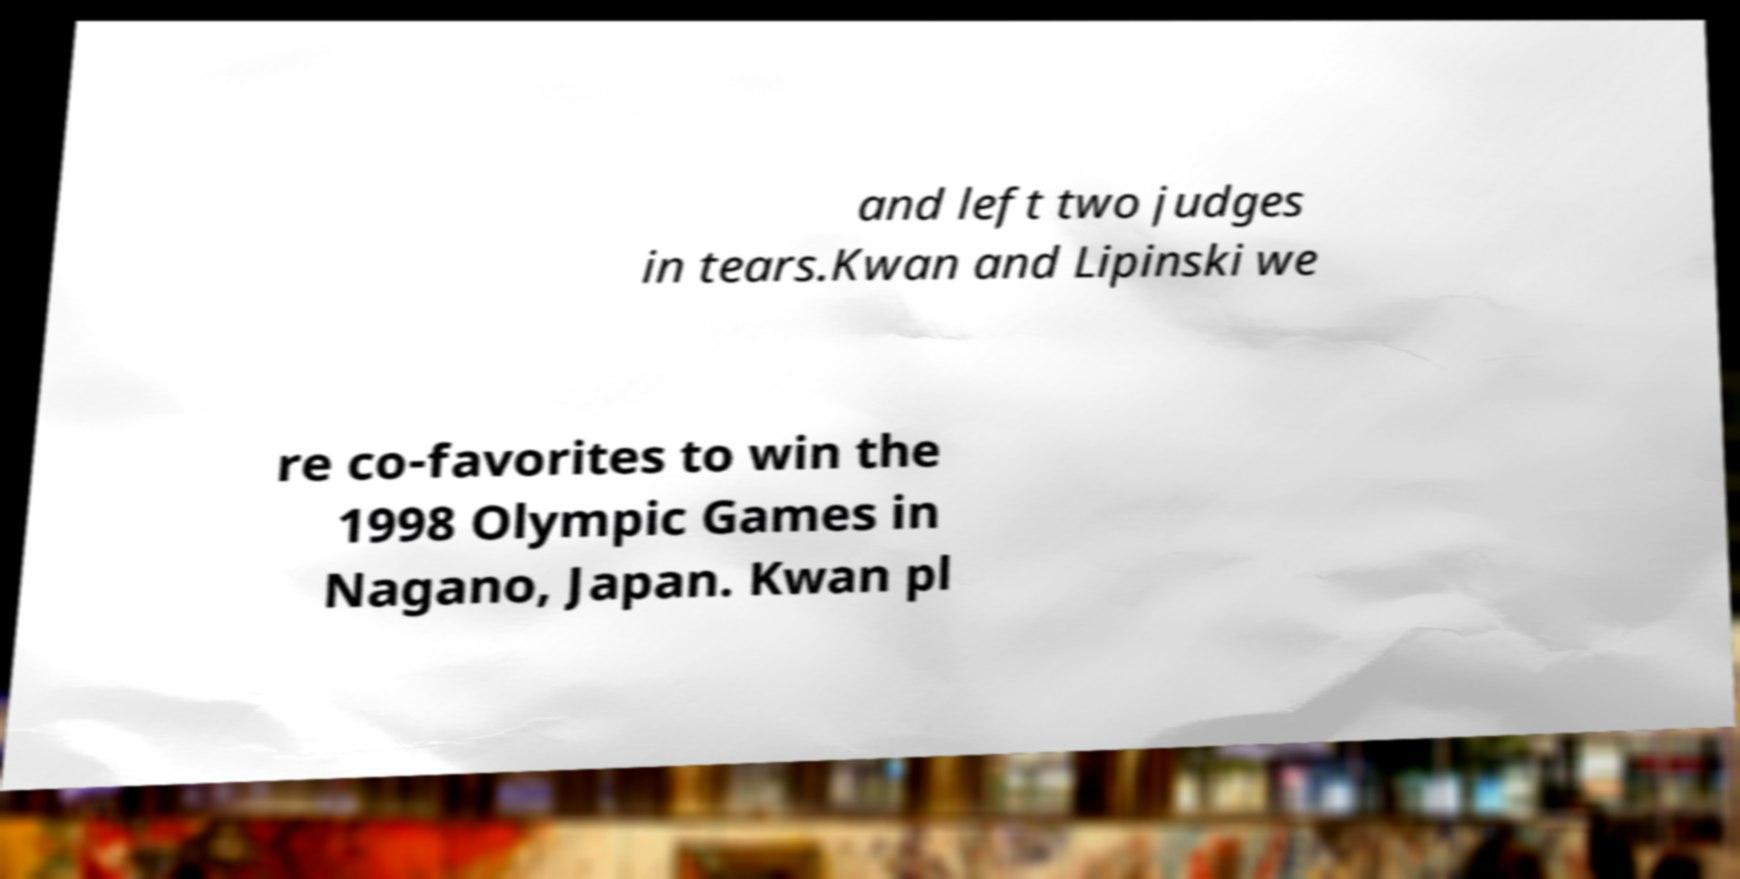Can you accurately transcribe the text from the provided image for me? and left two judges in tears.Kwan and Lipinski we re co-favorites to win the 1998 Olympic Games in Nagano, Japan. Kwan pl 